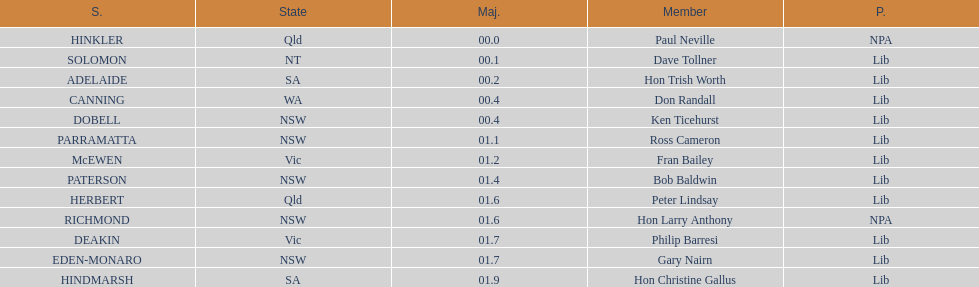What member comes next after hon trish worth? Don Randall. 